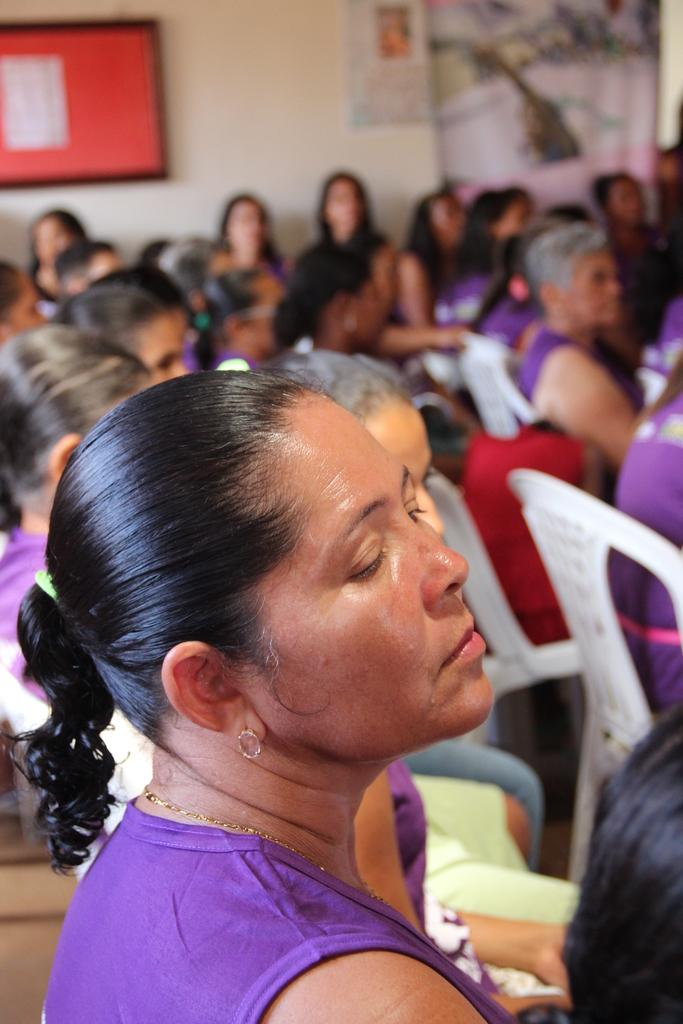Who is the main subject in the foreground of the image? There is a lady in the foreground of the image. What are the people in the background of the image doing? The people in the background of the image are sitting on chairs. What can be seen in the background of the image besides the people? There is a wall and a board in the background of the image. What type of cup is being used to measure the butter in the image? There is no cup or butter present in the image. What unit of measurement is being used to measure the butter in the image? There is no butter or unit of measurement present in the image. 